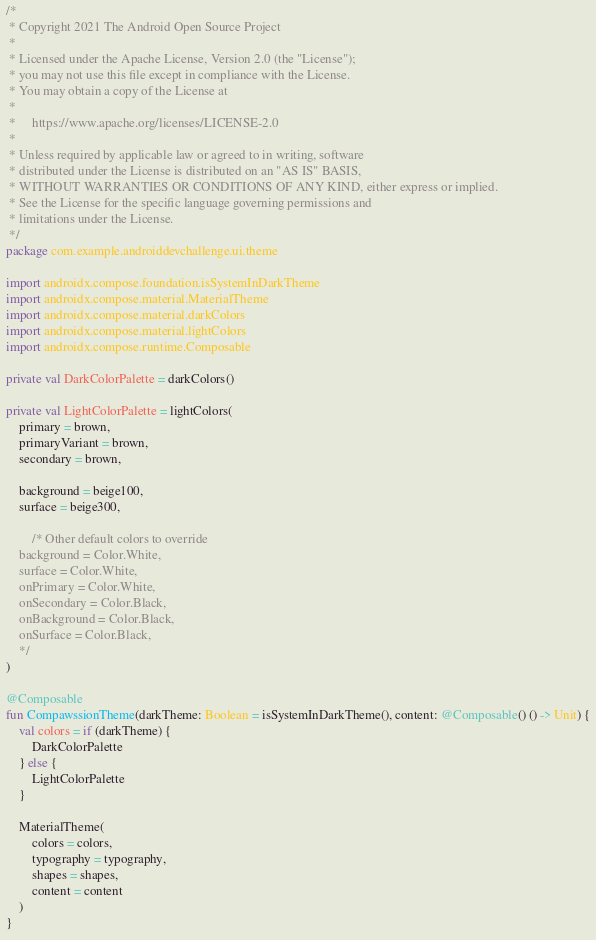Convert code to text. <code><loc_0><loc_0><loc_500><loc_500><_Kotlin_>/*
 * Copyright 2021 The Android Open Source Project
 *
 * Licensed under the Apache License, Version 2.0 (the "License");
 * you may not use this file except in compliance with the License.
 * You may obtain a copy of the License at
 *
 *     https://www.apache.org/licenses/LICENSE-2.0
 *
 * Unless required by applicable law or agreed to in writing, software
 * distributed under the License is distributed on an "AS IS" BASIS,
 * WITHOUT WARRANTIES OR CONDITIONS OF ANY KIND, either express or implied.
 * See the License for the specific language governing permissions and
 * limitations under the License.
 */
package com.example.androiddevchallenge.ui.theme

import androidx.compose.foundation.isSystemInDarkTheme
import androidx.compose.material.MaterialTheme
import androidx.compose.material.darkColors
import androidx.compose.material.lightColors
import androidx.compose.runtime.Composable

private val DarkColorPalette = darkColors()

private val LightColorPalette = lightColors(
    primary = brown,
    primaryVariant = brown,
    secondary = brown,

    background = beige100,
    surface = beige300,

        /* Other default colors to override
    background = Color.White,
    surface = Color.White,
    onPrimary = Color.White,
    onSecondary = Color.Black,
    onBackground = Color.Black,
    onSurface = Color.Black,
    */
)

@Composable
fun CompawssionTheme(darkTheme: Boolean = isSystemInDarkTheme(), content: @Composable() () -> Unit) {
    val colors = if (darkTheme) {
        DarkColorPalette
    } else {
        LightColorPalette
    }

    MaterialTheme(
        colors = colors,
        typography = typography,
        shapes = shapes,
        content = content
    )
}
</code> 